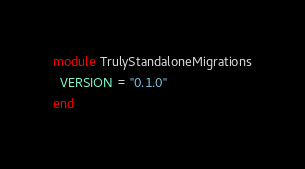Convert code to text. <code><loc_0><loc_0><loc_500><loc_500><_Ruby_>module TrulyStandaloneMigrations
  VERSION = "0.1.0"
end
</code> 